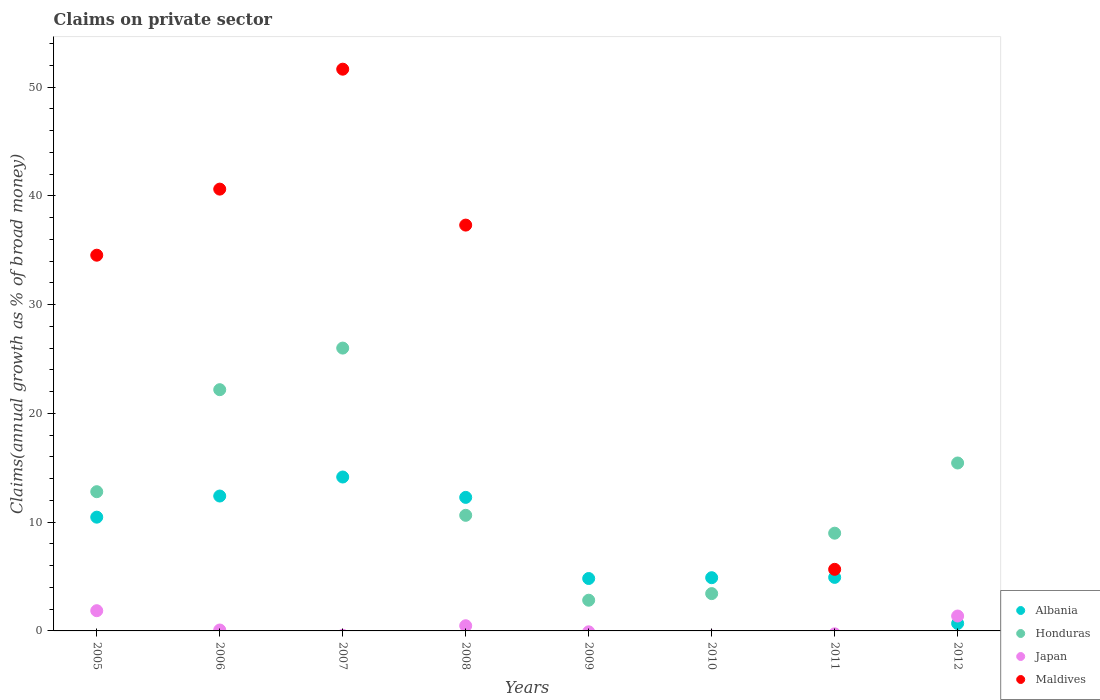How many different coloured dotlines are there?
Offer a terse response. 4. What is the percentage of broad money claimed on private sector in Albania in 2006?
Offer a terse response. 12.41. Across all years, what is the maximum percentage of broad money claimed on private sector in Maldives?
Your response must be concise. 51.66. What is the total percentage of broad money claimed on private sector in Honduras in the graph?
Offer a very short reply. 102.32. What is the difference between the percentage of broad money claimed on private sector in Honduras in 2006 and that in 2008?
Offer a terse response. 11.55. What is the difference between the percentage of broad money claimed on private sector in Honduras in 2011 and the percentage of broad money claimed on private sector in Japan in 2005?
Offer a terse response. 7.13. What is the average percentage of broad money claimed on private sector in Japan per year?
Your answer should be compact. 0.47. In the year 2009, what is the difference between the percentage of broad money claimed on private sector in Albania and percentage of broad money claimed on private sector in Honduras?
Your answer should be compact. 2. In how many years, is the percentage of broad money claimed on private sector in Albania greater than 50 %?
Offer a terse response. 0. What is the ratio of the percentage of broad money claimed on private sector in Japan in 2006 to that in 2012?
Provide a short and direct response. 0.06. Is the difference between the percentage of broad money claimed on private sector in Albania in 2005 and 2011 greater than the difference between the percentage of broad money claimed on private sector in Honduras in 2005 and 2011?
Offer a terse response. Yes. What is the difference between the highest and the second highest percentage of broad money claimed on private sector in Japan?
Provide a short and direct response. 0.49. What is the difference between the highest and the lowest percentage of broad money claimed on private sector in Japan?
Your answer should be very brief. 1.86. Is the sum of the percentage of broad money claimed on private sector in Honduras in 2006 and 2011 greater than the maximum percentage of broad money claimed on private sector in Maldives across all years?
Make the answer very short. No. Does the percentage of broad money claimed on private sector in Japan monotonically increase over the years?
Keep it short and to the point. No. Is the percentage of broad money claimed on private sector in Japan strictly greater than the percentage of broad money claimed on private sector in Albania over the years?
Give a very brief answer. No. Is the percentage of broad money claimed on private sector in Maldives strictly less than the percentage of broad money claimed on private sector in Japan over the years?
Your answer should be compact. No. How many dotlines are there?
Make the answer very short. 4. How many years are there in the graph?
Your response must be concise. 8. What is the difference between two consecutive major ticks on the Y-axis?
Ensure brevity in your answer.  10. Are the values on the major ticks of Y-axis written in scientific E-notation?
Give a very brief answer. No. Does the graph contain grids?
Your answer should be compact. No. How many legend labels are there?
Your answer should be compact. 4. How are the legend labels stacked?
Provide a succinct answer. Vertical. What is the title of the graph?
Provide a succinct answer. Claims on private sector. Does "Latin America(all income levels)" appear as one of the legend labels in the graph?
Your answer should be compact. No. What is the label or title of the X-axis?
Give a very brief answer. Years. What is the label or title of the Y-axis?
Make the answer very short. Claims(annual growth as % of broad money). What is the Claims(annual growth as % of broad money) of Albania in 2005?
Give a very brief answer. 10.46. What is the Claims(annual growth as % of broad money) in Honduras in 2005?
Provide a short and direct response. 12.8. What is the Claims(annual growth as % of broad money) of Japan in 2005?
Make the answer very short. 1.86. What is the Claims(annual growth as % of broad money) of Maldives in 2005?
Make the answer very short. 34.55. What is the Claims(annual growth as % of broad money) of Albania in 2006?
Provide a short and direct response. 12.41. What is the Claims(annual growth as % of broad money) in Honduras in 2006?
Provide a succinct answer. 22.19. What is the Claims(annual growth as % of broad money) of Japan in 2006?
Provide a short and direct response. 0.08. What is the Claims(annual growth as % of broad money) in Maldives in 2006?
Make the answer very short. 40.63. What is the Claims(annual growth as % of broad money) in Albania in 2007?
Your answer should be very brief. 14.15. What is the Claims(annual growth as % of broad money) of Honduras in 2007?
Make the answer very short. 26.01. What is the Claims(annual growth as % of broad money) in Japan in 2007?
Your answer should be compact. 0. What is the Claims(annual growth as % of broad money) in Maldives in 2007?
Keep it short and to the point. 51.66. What is the Claims(annual growth as % of broad money) in Albania in 2008?
Your answer should be compact. 12.28. What is the Claims(annual growth as % of broad money) of Honduras in 2008?
Make the answer very short. 10.63. What is the Claims(annual growth as % of broad money) of Japan in 2008?
Give a very brief answer. 0.48. What is the Claims(annual growth as % of broad money) of Maldives in 2008?
Give a very brief answer. 37.32. What is the Claims(annual growth as % of broad money) of Albania in 2009?
Ensure brevity in your answer.  4.82. What is the Claims(annual growth as % of broad money) in Honduras in 2009?
Make the answer very short. 2.82. What is the Claims(annual growth as % of broad money) in Maldives in 2009?
Ensure brevity in your answer.  0. What is the Claims(annual growth as % of broad money) of Albania in 2010?
Your answer should be compact. 4.89. What is the Claims(annual growth as % of broad money) in Honduras in 2010?
Your answer should be very brief. 3.43. What is the Claims(annual growth as % of broad money) in Albania in 2011?
Your response must be concise. 4.92. What is the Claims(annual growth as % of broad money) of Honduras in 2011?
Ensure brevity in your answer.  8.99. What is the Claims(annual growth as % of broad money) of Maldives in 2011?
Offer a very short reply. 5.66. What is the Claims(annual growth as % of broad money) of Albania in 2012?
Make the answer very short. 0.69. What is the Claims(annual growth as % of broad money) in Honduras in 2012?
Keep it short and to the point. 15.44. What is the Claims(annual growth as % of broad money) in Japan in 2012?
Make the answer very short. 1.37. What is the Claims(annual growth as % of broad money) of Maldives in 2012?
Make the answer very short. 0. Across all years, what is the maximum Claims(annual growth as % of broad money) in Albania?
Your answer should be compact. 14.15. Across all years, what is the maximum Claims(annual growth as % of broad money) in Honduras?
Keep it short and to the point. 26.01. Across all years, what is the maximum Claims(annual growth as % of broad money) in Japan?
Offer a terse response. 1.86. Across all years, what is the maximum Claims(annual growth as % of broad money) of Maldives?
Provide a succinct answer. 51.66. Across all years, what is the minimum Claims(annual growth as % of broad money) in Albania?
Provide a short and direct response. 0.69. Across all years, what is the minimum Claims(annual growth as % of broad money) of Honduras?
Your answer should be very brief. 2.82. Across all years, what is the minimum Claims(annual growth as % of broad money) of Japan?
Your answer should be very brief. 0. Across all years, what is the minimum Claims(annual growth as % of broad money) in Maldives?
Provide a succinct answer. 0. What is the total Claims(annual growth as % of broad money) of Albania in the graph?
Ensure brevity in your answer.  64.63. What is the total Claims(annual growth as % of broad money) of Honduras in the graph?
Your answer should be very brief. 102.32. What is the total Claims(annual growth as % of broad money) in Japan in the graph?
Ensure brevity in your answer.  3.79. What is the total Claims(annual growth as % of broad money) of Maldives in the graph?
Keep it short and to the point. 169.83. What is the difference between the Claims(annual growth as % of broad money) of Albania in 2005 and that in 2006?
Give a very brief answer. -1.94. What is the difference between the Claims(annual growth as % of broad money) in Honduras in 2005 and that in 2006?
Provide a succinct answer. -9.38. What is the difference between the Claims(annual growth as % of broad money) in Japan in 2005 and that in 2006?
Your answer should be very brief. 1.78. What is the difference between the Claims(annual growth as % of broad money) of Maldives in 2005 and that in 2006?
Provide a short and direct response. -6.08. What is the difference between the Claims(annual growth as % of broad money) of Albania in 2005 and that in 2007?
Provide a short and direct response. -3.69. What is the difference between the Claims(annual growth as % of broad money) of Honduras in 2005 and that in 2007?
Keep it short and to the point. -13.21. What is the difference between the Claims(annual growth as % of broad money) of Maldives in 2005 and that in 2007?
Provide a short and direct response. -17.11. What is the difference between the Claims(annual growth as % of broad money) in Albania in 2005 and that in 2008?
Provide a succinct answer. -1.82. What is the difference between the Claims(annual growth as % of broad money) of Honduras in 2005 and that in 2008?
Your answer should be very brief. 2.17. What is the difference between the Claims(annual growth as % of broad money) of Japan in 2005 and that in 2008?
Keep it short and to the point. 1.38. What is the difference between the Claims(annual growth as % of broad money) of Maldives in 2005 and that in 2008?
Make the answer very short. -2.77. What is the difference between the Claims(annual growth as % of broad money) of Albania in 2005 and that in 2009?
Offer a terse response. 5.64. What is the difference between the Claims(annual growth as % of broad money) in Honduras in 2005 and that in 2009?
Provide a short and direct response. 9.98. What is the difference between the Claims(annual growth as % of broad money) in Albania in 2005 and that in 2010?
Your response must be concise. 5.57. What is the difference between the Claims(annual growth as % of broad money) in Honduras in 2005 and that in 2010?
Provide a succinct answer. 9.37. What is the difference between the Claims(annual growth as % of broad money) in Albania in 2005 and that in 2011?
Provide a succinct answer. 5.54. What is the difference between the Claims(annual growth as % of broad money) of Honduras in 2005 and that in 2011?
Your answer should be very brief. 3.82. What is the difference between the Claims(annual growth as % of broad money) of Maldives in 2005 and that in 2011?
Your answer should be very brief. 28.89. What is the difference between the Claims(annual growth as % of broad money) of Albania in 2005 and that in 2012?
Your response must be concise. 9.77. What is the difference between the Claims(annual growth as % of broad money) of Honduras in 2005 and that in 2012?
Your answer should be very brief. -2.64. What is the difference between the Claims(annual growth as % of broad money) in Japan in 2005 and that in 2012?
Ensure brevity in your answer.  0.49. What is the difference between the Claims(annual growth as % of broad money) in Albania in 2006 and that in 2007?
Give a very brief answer. -1.75. What is the difference between the Claims(annual growth as % of broad money) of Honduras in 2006 and that in 2007?
Give a very brief answer. -3.83. What is the difference between the Claims(annual growth as % of broad money) in Maldives in 2006 and that in 2007?
Provide a succinct answer. -11.03. What is the difference between the Claims(annual growth as % of broad money) of Albania in 2006 and that in 2008?
Keep it short and to the point. 0.12. What is the difference between the Claims(annual growth as % of broad money) in Honduras in 2006 and that in 2008?
Ensure brevity in your answer.  11.55. What is the difference between the Claims(annual growth as % of broad money) of Japan in 2006 and that in 2008?
Your answer should be very brief. -0.39. What is the difference between the Claims(annual growth as % of broad money) in Maldives in 2006 and that in 2008?
Your answer should be very brief. 3.31. What is the difference between the Claims(annual growth as % of broad money) of Albania in 2006 and that in 2009?
Offer a very short reply. 7.58. What is the difference between the Claims(annual growth as % of broad money) of Honduras in 2006 and that in 2009?
Offer a terse response. 19.36. What is the difference between the Claims(annual growth as % of broad money) of Albania in 2006 and that in 2010?
Your answer should be very brief. 7.51. What is the difference between the Claims(annual growth as % of broad money) in Honduras in 2006 and that in 2010?
Your response must be concise. 18.75. What is the difference between the Claims(annual growth as % of broad money) of Albania in 2006 and that in 2011?
Offer a very short reply. 7.48. What is the difference between the Claims(annual growth as % of broad money) of Honduras in 2006 and that in 2011?
Provide a succinct answer. 13.2. What is the difference between the Claims(annual growth as % of broad money) in Maldives in 2006 and that in 2011?
Give a very brief answer. 34.97. What is the difference between the Claims(annual growth as % of broad money) in Albania in 2006 and that in 2012?
Offer a terse response. 11.72. What is the difference between the Claims(annual growth as % of broad money) in Honduras in 2006 and that in 2012?
Offer a very short reply. 6.74. What is the difference between the Claims(annual growth as % of broad money) of Japan in 2006 and that in 2012?
Ensure brevity in your answer.  -1.29. What is the difference between the Claims(annual growth as % of broad money) in Albania in 2007 and that in 2008?
Offer a very short reply. 1.87. What is the difference between the Claims(annual growth as % of broad money) in Honduras in 2007 and that in 2008?
Your response must be concise. 15.38. What is the difference between the Claims(annual growth as % of broad money) of Maldives in 2007 and that in 2008?
Ensure brevity in your answer.  14.34. What is the difference between the Claims(annual growth as % of broad money) of Albania in 2007 and that in 2009?
Provide a succinct answer. 9.33. What is the difference between the Claims(annual growth as % of broad money) of Honduras in 2007 and that in 2009?
Ensure brevity in your answer.  23.19. What is the difference between the Claims(annual growth as % of broad money) in Albania in 2007 and that in 2010?
Your response must be concise. 9.26. What is the difference between the Claims(annual growth as % of broad money) of Honduras in 2007 and that in 2010?
Your answer should be very brief. 22.58. What is the difference between the Claims(annual growth as % of broad money) in Albania in 2007 and that in 2011?
Make the answer very short. 9.23. What is the difference between the Claims(annual growth as % of broad money) of Honduras in 2007 and that in 2011?
Your response must be concise. 17.02. What is the difference between the Claims(annual growth as % of broad money) of Maldives in 2007 and that in 2011?
Make the answer very short. 46. What is the difference between the Claims(annual growth as % of broad money) in Albania in 2007 and that in 2012?
Provide a short and direct response. 13.47. What is the difference between the Claims(annual growth as % of broad money) of Honduras in 2007 and that in 2012?
Your response must be concise. 10.57. What is the difference between the Claims(annual growth as % of broad money) in Albania in 2008 and that in 2009?
Keep it short and to the point. 7.46. What is the difference between the Claims(annual growth as % of broad money) in Honduras in 2008 and that in 2009?
Your answer should be very brief. 7.81. What is the difference between the Claims(annual growth as % of broad money) in Albania in 2008 and that in 2010?
Offer a very short reply. 7.39. What is the difference between the Claims(annual growth as % of broad money) in Honduras in 2008 and that in 2010?
Keep it short and to the point. 7.2. What is the difference between the Claims(annual growth as % of broad money) of Albania in 2008 and that in 2011?
Offer a very short reply. 7.36. What is the difference between the Claims(annual growth as % of broad money) of Honduras in 2008 and that in 2011?
Make the answer very short. 1.64. What is the difference between the Claims(annual growth as % of broad money) in Maldives in 2008 and that in 2011?
Your answer should be very brief. 31.66. What is the difference between the Claims(annual growth as % of broad money) in Albania in 2008 and that in 2012?
Keep it short and to the point. 11.59. What is the difference between the Claims(annual growth as % of broad money) in Honduras in 2008 and that in 2012?
Offer a very short reply. -4.81. What is the difference between the Claims(annual growth as % of broad money) in Japan in 2008 and that in 2012?
Give a very brief answer. -0.89. What is the difference between the Claims(annual growth as % of broad money) in Albania in 2009 and that in 2010?
Provide a short and direct response. -0.07. What is the difference between the Claims(annual growth as % of broad money) of Honduras in 2009 and that in 2010?
Ensure brevity in your answer.  -0.61. What is the difference between the Claims(annual growth as % of broad money) in Albania in 2009 and that in 2011?
Your answer should be compact. -0.1. What is the difference between the Claims(annual growth as % of broad money) in Honduras in 2009 and that in 2011?
Your answer should be very brief. -6.16. What is the difference between the Claims(annual growth as % of broad money) in Albania in 2009 and that in 2012?
Provide a short and direct response. 4.13. What is the difference between the Claims(annual growth as % of broad money) in Honduras in 2009 and that in 2012?
Offer a terse response. -12.62. What is the difference between the Claims(annual growth as % of broad money) of Albania in 2010 and that in 2011?
Keep it short and to the point. -0.03. What is the difference between the Claims(annual growth as % of broad money) of Honduras in 2010 and that in 2011?
Provide a short and direct response. -5.56. What is the difference between the Claims(annual growth as % of broad money) of Albania in 2010 and that in 2012?
Ensure brevity in your answer.  4.21. What is the difference between the Claims(annual growth as % of broad money) of Honduras in 2010 and that in 2012?
Offer a terse response. -12.01. What is the difference between the Claims(annual growth as % of broad money) of Albania in 2011 and that in 2012?
Keep it short and to the point. 4.24. What is the difference between the Claims(annual growth as % of broad money) of Honduras in 2011 and that in 2012?
Keep it short and to the point. -6.46. What is the difference between the Claims(annual growth as % of broad money) of Albania in 2005 and the Claims(annual growth as % of broad money) of Honduras in 2006?
Your answer should be very brief. -11.72. What is the difference between the Claims(annual growth as % of broad money) in Albania in 2005 and the Claims(annual growth as % of broad money) in Japan in 2006?
Ensure brevity in your answer.  10.38. What is the difference between the Claims(annual growth as % of broad money) in Albania in 2005 and the Claims(annual growth as % of broad money) in Maldives in 2006?
Provide a short and direct response. -30.17. What is the difference between the Claims(annual growth as % of broad money) of Honduras in 2005 and the Claims(annual growth as % of broad money) of Japan in 2006?
Offer a terse response. 12.72. What is the difference between the Claims(annual growth as % of broad money) in Honduras in 2005 and the Claims(annual growth as % of broad money) in Maldives in 2006?
Provide a succinct answer. -27.83. What is the difference between the Claims(annual growth as % of broad money) in Japan in 2005 and the Claims(annual growth as % of broad money) in Maldives in 2006?
Your answer should be compact. -38.77. What is the difference between the Claims(annual growth as % of broad money) of Albania in 2005 and the Claims(annual growth as % of broad money) of Honduras in 2007?
Ensure brevity in your answer.  -15.55. What is the difference between the Claims(annual growth as % of broad money) in Albania in 2005 and the Claims(annual growth as % of broad money) in Maldives in 2007?
Give a very brief answer. -41.2. What is the difference between the Claims(annual growth as % of broad money) of Honduras in 2005 and the Claims(annual growth as % of broad money) of Maldives in 2007?
Offer a terse response. -38.86. What is the difference between the Claims(annual growth as % of broad money) in Japan in 2005 and the Claims(annual growth as % of broad money) in Maldives in 2007?
Provide a succinct answer. -49.8. What is the difference between the Claims(annual growth as % of broad money) in Albania in 2005 and the Claims(annual growth as % of broad money) in Honduras in 2008?
Offer a very short reply. -0.17. What is the difference between the Claims(annual growth as % of broad money) in Albania in 2005 and the Claims(annual growth as % of broad money) in Japan in 2008?
Provide a short and direct response. 9.99. What is the difference between the Claims(annual growth as % of broad money) of Albania in 2005 and the Claims(annual growth as % of broad money) of Maldives in 2008?
Offer a terse response. -26.86. What is the difference between the Claims(annual growth as % of broad money) of Honduras in 2005 and the Claims(annual growth as % of broad money) of Japan in 2008?
Provide a succinct answer. 12.33. What is the difference between the Claims(annual growth as % of broad money) of Honduras in 2005 and the Claims(annual growth as % of broad money) of Maldives in 2008?
Your answer should be very brief. -24.52. What is the difference between the Claims(annual growth as % of broad money) of Japan in 2005 and the Claims(annual growth as % of broad money) of Maldives in 2008?
Offer a terse response. -35.46. What is the difference between the Claims(annual growth as % of broad money) of Albania in 2005 and the Claims(annual growth as % of broad money) of Honduras in 2009?
Make the answer very short. 7.64. What is the difference between the Claims(annual growth as % of broad money) in Albania in 2005 and the Claims(annual growth as % of broad money) in Honduras in 2010?
Make the answer very short. 7.03. What is the difference between the Claims(annual growth as % of broad money) in Albania in 2005 and the Claims(annual growth as % of broad money) in Honduras in 2011?
Provide a short and direct response. 1.47. What is the difference between the Claims(annual growth as % of broad money) in Albania in 2005 and the Claims(annual growth as % of broad money) in Maldives in 2011?
Your answer should be very brief. 4.8. What is the difference between the Claims(annual growth as % of broad money) in Honduras in 2005 and the Claims(annual growth as % of broad money) in Maldives in 2011?
Ensure brevity in your answer.  7.14. What is the difference between the Claims(annual growth as % of broad money) of Japan in 2005 and the Claims(annual growth as % of broad money) of Maldives in 2011?
Ensure brevity in your answer.  -3.8. What is the difference between the Claims(annual growth as % of broad money) in Albania in 2005 and the Claims(annual growth as % of broad money) in Honduras in 2012?
Offer a very short reply. -4.98. What is the difference between the Claims(annual growth as % of broad money) in Albania in 2005 and the Claims(annual growth as % of broad money) in Japan in 2012?
Provide a succinct answer. 9.09. What is the difference between the Claims(annual growth as % of broad money) in Honduras in 2005 and the Claims(annual growth as % of broad money) in Japan in 2012?
Make the answer very short. 11.43. What is the difference between the Claims(annual growth as % of broad money) in Albania in 2006 and the Claims(annual growth as % of broad money) in Honduras in 2007?
Your answer should be very brief. -13.61. What is the difference between the Claims(annual growth as % of broad money) of Albania in 2006 and the Claims(annual growth as % of broad money) of Maldives in 2007?
Your answer should be very brief. -39.26. What is the difference between the Claims(annual growth as % of broad money) in Honduras in 2006 and the Claims(annual growth as % of broad money) in Maldives in 2007?
Give a very brief answer. -29.48. What is the difference between the Claims(annual growth as % of broad money) in Japan in 2006 and the Claims(annual growth as % of broad money) in Maldives in 2007?
Offer a very short reply. -51.58. What is the difference between the Claims(annual growth as % of broad money) of Albania in 2006 and the Claims(annual growth as % of broad money) of Honduras in 2008?
Your response must be concise. 1.77. What is the difference between the Claims(annual growth as % of broad money) of Albania in 2006 and the Claims(annual growth as % of broad money) of Japan in 2008?
Provide a succinct answer. 11.93. What is the difference between the Claims(annual growth as % of broad money) in Albania in 2006 and the Claims(annual growth as % of broad money) in Maldives in 2008?
Ensure brevity in your answer.  -24.92. What is the difference between the Claims(annual growth as % of broad money) in Honduras in 2006 and the Claims(annual growth as % of broad money) in Japan in 2008?
Your response must be concise. 21.71. What is the difference between the Claims(annual growth as % of broad money) of Honduras in 2006 and the Claims(annual growth as % of broad money) of Maldives in 2008?
Your answer should be very brief. -15.14. What is the difference between the Claims(annual growth as % of broad money) of Japan in 2006 and the Claims(annual growth as % of broad money) of Maldives in 2008?
Your response must be concise. -37.24. What is the difference between the Claims(annual growth as % of broad money) in Albania in 2006 and the Claims(annual growth as % of broad money) in Honduras in 2009?
Give a very brief answer. 9.58. What is the difference between the Claims(annual growth as % of broad money) in Albania in 2006 and the Claims(annual growth as % of broad money) in Honduras in 2010?
Provide a short and direct response. 8.97. What is the difference between the Claims(annual growth as % of broad money) of Albania in 2006 and the Claims(annual growth as % of broad money) of Honduras in 2011?
Your answer should be very brief. 3.42. What is the difference between the Claims(annual growth as % of broad money) of Albania in 2006 and the Claims(annual growth as % of broad money) of Maldives in 2011?
Keep it short and to the point. 6.74. What is the difference between the Claims(annual growth as % of broad money) in Honduras in 2006 and the Claims(annual growth as % of broad money) in Maldives in 2011?
Make the answer very short. 16.52. What is the difference between the Claims(annual growth as % of broad money) in Japan in 2006 and the Claims(annual growth as % of broad money) in Maldives in 2011?
Offer a terse response. -5.58. What is the difference between the Claims(annual growth as % of broad money) in Albania in 2006 and the Claims(annual growth as % of broad money) in Honduras in 2012?
Give a very brief answer. -3.04. What is the difference between the Claims(annual growth as % of broad money) in Albania in 2006 and the Claims(annual growth as % of broad money) in Japan in 2012?
Ensure brevity in your answer.  11.03. What is the difference between the Claims(annual growth as % of broad money) in Honduras in 2006 and the Claims(annual growth as % of broad money) in Japan in 2012?
Your answer should be very brief. 20.81. What is the difference between the Claims(annual growth as % of broad money) of Albania in 2007 and the Claims(annual growth as % of broad money) of Honduras in 2008?
Your answer should be very brief. 3.52. What is the difference between the Claims(annual growth as % of broad money) of Albania in 2007 and the Claims(annual growth as % of broad money) of Japan in 2008?
Keep it short and to the point. 13.68. What is the difference between the Claims(annual growth as % of broad money) in Albania in 2007 and the Claims(annual growth as % of broad money) in Maldives in 2008?
Make the answer very short. -23.17. What is the difference between the Claims(annual growth as % of broad money) of Honduras in 2007 and the Claims(annual growth as % of broad money) of Japan in 2008?
Offer a terse response. 25.53. What is the difference between the Claims(annual growth as % of broad money) of Honduras in 2007 and the Claims(annual growth as % of broad money) of Maldives in 2008?
Provide a succinct answer. -11.31. What is the difference between the Claims(annual growth as % of broad money) in Albania in 2007 and the Claims(annual growth as % of broad money) in Honduras in 2009?
Make the answer very short. 11.33. What is the difference between the Claims(annual growth as % of broad money) of Albania in 2007 and the Claims(annual growth as % of broad money) of Honduras in 2010?
Provide a short and direct response. 10.72. What is the difference between the Claims(annual growth as % of broad money) in Albania in 2007 and the Claims(annual growth as % of broad money) in Honduras in 2011?
Offer a terse response. 5.17. What is the difference between the Claims(annual growth as % of broad money) in Albania in 2007 and the Claims(annual growth as % of broad money) in Maldives in 2011?
Offer a terse response. 8.49. What is the difference between the Claims(annual growth as % of broad money) in Honduras in 2007 and the Claims(annual growth as % of broad money) in Maldives in 2011?
Your answer should be very brief. 20.35. What is the difference between the Claims(annual growth as % of broad money) in Albania in 2007 and the Claims(annual growth as % of broad money) in Honduras in 2012?
Your response must be concise. -1.29. What is the difference between the Claims(annual growth as % of broad money) of Albania in 2007 and the Claims(annual growth as % of broad money) of Japan in 2012?
Your answer should be compact. 12.78. What is the difference between the Claims(annual growth as % of broad money) in Honduras in 2007 and the Claims(annual growth as % of broad money) in Japan in 2012?
Provide a short and direct response. 24.64. What is the difference between the Claims(annual growth as % of broad money) in Albania in 2008 and the Claims(annual growth as % of broad money) in Honduras in 2009?
Provide a short and direct response. 9.46. What is the difference between the Claims(annual growth as % of broad money) of Albania in 2008 and the Claims(annual growth as % of broad money) of Honduras in 2010?
Offer a very short reply. 8.85. What is the difference between the Claims(annual growth as % of broad money) of Albania in 2008 and the Claims(annual growth as % of broad money) of Honduras in 2011?
Ensure brevity in your answer.  3.29. What is the difference between the Claims(annual growth as % of broad money) in Albania in 2008 and the Claims(annual growth as % of broad money) in Maldives in 2011?
Keep it short and to the point. 6.62. What is the difference between the Claims(annual growth as % of broad money) in Honduras in 2008 and the Claims(annual growth as % of broad money) in Maldives in 2011?
Provide a short and direct response. 4.97. What is the difference between the Claims(annual growth as % of broad money) in Japan in 2008 and the Claims(annual growth as % of broad money) in Maldives in 2011?
Offer a terse response. -5.19. What is the difference between the Claims(annual growth as % of broad money) in Albania in 2008 and the Claims(annual growth as % of broad money) in Honduras in 2012?
Your answer should be very brief. -3.16. What is the difference between the Claims(annual growth as % of broad money) of Albania in 2008 and the Claims(annual growth as % of broad money) of Japan in 2012?
Give a very brief answer. 10.91. What is the difference between the Claims(annual growth as % of broad money) in Honduras in 2008 and the Claims(annual growth as % of broad money) in Japan in 2012?
Provide a short and direct response. 9.26. What is the difference between the Claims(annual growth as % of broad money) in Albania in 2009 and the Claims(annual growth as % of broad money) in Honduras in 2010?
Provide a short and direct response. 1.39. What is the difference between the Claims(annual growth as % of broad money) in Albania in 2009 and the Claims(annual growth as % of broad money) in Honduras in 2011?
Your response must be concise. -4.17. What is the difference between the Claims(annual growth as % of broad money) of Albania in 2009 and the Claims(annual growth as % of broad money) of Maldives in 2011?
Your answer should be compact. -0.84. What is the difference between the Claims(annual growth as % of broad money) of Honduras in 2009 and the Claims(annual growth as % of broad money) of Maldives in 2011?
Keep it short and to the point. -2.84. What is the difference between the Claims(annual growth as % of broad money) of Albania in 2009 and the Claims(annual growth as % of broad money) of Honduras in 2012?
Provide a succinct answer. -10.62. What is the difference between the Claims(annual growth as % of broad money) in Albania in 2009 and the Claims(annual growth as % of broad money) in Japan in 2012?
Keep it short and to the point. 3.45. What is the difference between the Claims(annual growth as % of broad money) in Honduras in 2009 and the Claims(annual growth as % of broad money) in Japan in 2012?
Provide a short and direct response. 1.45. What is the difference between the Claims(annual growth as % of broad money) of Albania in 2010 and the Claims(annual growth as % of broad money) of Honduras in 2011?
Offer a very short reply. -4.09. What is the difference between the Claims(annual growth as % of broad money) in Albania in 2010 and the Claims(annual growth as % of broad money) in Maldives in 2011?
Your response must be concise. -0.77. What is the difference between the Claims(annual growth as % of broad money) in Honduras in 2010 and the Claims(annual growth as % of broad money) in Maldives in 2011?
Offer a terse response. -2.23. What is the difference between the Claims(annual growth as % of broad money) of Albania in 2010 and the Claims(annual growth as % of broad money) of Honduras in 2012?
Give a very brief answer. -10.55. What is the difference between the Claims(annual growth as % of broad money) in Albania in 2010 and the Claims(annual growth as % of broad money) in Japan in 2012?
Your answer should be very brief. 3.52. What is the difference between the Claims(annual growth as % of broad money) in Honduras in 2010 and the Claims(annual growth as % of broad money) in Japan in 2012?
Ensure brevity in your answer.  2.06. What is the difference between the Claims(annual growth as % of broad money) of Albania in 2011 and the Claims(annual growth as % of broad money) of Honduras in 2012?
Ensure brevity in your answer.  -10.52. What is the difference between the Claims(annual growth as % of broad money) in Albania in 2011 and the Claims(annual growth as % of broad money) in Japan in 2012?
Offer a very short reply. 3.55. What is the difference between the Claims(annual growth as % of broad money) in Honduras in 2011 and the Claims(annual growth as % of broad money) in Japan in 2012?
Make the answer very short. 7.62. What is the average Claims(annual growth as % of broad money) in Albania per year?
Make the answer very short. 8.08. What is the average Claims(annual growth as % of broad money) of Honduras per year?
Provide a succinct answer. 12.79. What is the average Claims(annual growth as % of broad money) in Japan per year?
Keep it short and to the point. 0.47. What is the average Claims(annual growth as % of broad money) in Maldives per year?
Provide a short and direct response. 21.23. In the year 2005, what is the difference between the Claims(annual growth as % of broad money) of Albania and Claims(annual growth as % of broad money) of Honduras?
Your answer should be very brief. -2.34. In the year 2005, what is the difference between the Claims(annual growth as % of broad money) of Albania and Claims(annual growth as % of broad money) of Japan?
Make the answer very short. 8.6. In the year 2005, what is the difference between the Claims(annual growth as % of broad money) in Albania and Claims(annual growth as % of broad money) in Maldives?
Your answer should be compact. -24.09. In the year 2005, what is the difference between the Claims(annual growth as % of broad money) of Honduras and Claims(annual growth as % of broad money) of Japan?
Provide a succinct answer. 10.94. In the year 2005, what is the difference between the Claims(annual growth as % of broad money) of Honduras and Claims(annual growth as % of broad money) of Maldives?
Provide a short and direct response. -21.75. In the year 2005, what is the difference between the Claims(annual growth as % of broad money) in Japan and Claims(annual growth as % of broad money) in Maldives?
Provide a succinct answer. -32.69. In the year 2006, what is the difference between the Claims(annual growth as % of broad money) in Albania and Claims(annual growth as % of broad money) in Honduras?
Keep it short and to the point. -9.78. In the year 2006, what is the difference between the Claims(annual growth as % of broad money) of Albania and Claims(annual growth as % of broad money) of Japan?
Provide a succinct answer. 12.32. In the year 2006, what is the difference between the Claims(annual growth as % of broad money) in Albania and Claims(annual growth as % of broad money) in Maldives?
Offer a very short reply. -28.23. In the year 2006, what is the difference between the Claims(annual growth as % of broad money) in Honduras and Claims(annual growth as % of broad money) in Japan?
Ensure brevity in your answer.  22.1. In the year 2006, what is the difference between the Claims(annual growth as % of broad money) in Honduras and Claims(annual growth as % of broad money) in Maldives?
Your answer should be compact. -18.45. In the year 2006, what is the difference between the Claims(annual growth as % of broad money) of Japan and Claims(annual growth as % of broad money) of Maldives?
Your response must be concise. -40.55. In the year 2007, what is the difference between the Claims(annual growth as % of broad money) in Albania and Claims(annual growth as % of broad money) in Honduras?
Your answer should be compact. -11.86. In the year 2007, what is the difference between the Claims(annual growth as % of broad money) of Albania and Claims(annual growth as % of broad money) of Maldives?
Offer a very short reply. -37.51. In the year 2007, what is the difference between the Claims(annual growth as % of broad money) in Honduras and Claims(annual growth as % of broad money) in Maldives?
Ensure brevity in your answer.  -25.65. In the year 2008, what is the difference between the Claims(annual growth as % of broad money) of Albania and Claims(annual growth as % of broad money) of Honduras?
Your answer should be compact. 1.65. In the year 2008, what is the difference between the Claims(annual growth as % of broad money) in Albania and Claims(annual growth as % of broad money) in Japan?
Give a very brief answer. 11.8. In the year 2008, what is the difference between the Claims(annual growth as % of broad money) in Albania and Claims(annual growth as % of broad money) in Maldives?
Keep it short and to the point. -25.04. In the year 2008, what is the difference between the Claims(annual growth as % of broad money) of Honduras and Claims(annual growth as % of broad money) of Japan?
Ensure brevity in your answer.  10.15. In the year 2008, what is the difference between the Claims(annual growth as % of broad money) in Honduras and Claims(annual growth as % of broad money) in Maldives?
Provide a succinct answer. -26.69. In the year 2008, what is the difference between the Claims(annual growth as % of broad money) in Japan and Claims(annual growth as % of broad money) in Maldives?
Your answer should be very brief. -36.85. In the year 2009, what is the difference between the Claims(annual growth as % of broad money) of Albania and Claims(annual growth as % of broad money) of Honduras?
Give a very brief answer. 2. In the year 2010, what is the difference between the Claims(annual growth as % of broad money) in Albania and Claims(annual growth as % of broad money) in Honduras?
Your answer should be very brief. 1.46. In the year 2011, what is the difference between the Claims(annual growth as % of broad money) of Albania and Claims(annual growth as % of broad money) of Honduras?
Keep it short and to the point. -4.06. In the year 2011, what is the difference between the Claims(annual growth as % of broad money) of Albania and Claims(annual growth as % of broad money) of Maldives?
Offer a terse response. -0.74. In the year 2011, what is the difference between the Claims(annual growth as % of broad money) in Honduras and Claims(annual growth as % of broad money) in Maldives?
Keep it short and to the point. 3.33. In the year 2012, what is the difference between the Claims(annual growth as % of broad money) of Albania and Claims(annual growth as % of broad money) of Honduras?
Give a very brief answer. -14.76. In the year 2012, what is the difference between the Claims(annual growth as % of broad money) of Albania and Claims(annual growth as % of broad money) of Japan?
Keep it short and to the point. -0.68. In the year 2012, what is the difference between the Claims(annual growth as % of broad money) of Honduras and Claims(annual growth as % of broad money) of Japan?
Your answer should be very brief. 14.07. What is the ratio of the Claims(annual growth as % of broad money) in Albania in 2005 to that in 2006?
Your answer should be compact. 0.84. What is the ratio of the Claims(annual growth as % of broad money) of Honduras in 2005 to that in 2006?
Provide a succinct answer. 0.58. What is the ratio of the Claims(annual growth as % of broad money) in Japan in 2005 to that in 2006?
Your answer should be very brief. 22.02. What is the ratio of the Claims(annual growth as % of broad money) of Maldives in 2005 to that in 2006?
Provide a succinct answer. 0.85. What is the ratio of the Claims(annual growth as % of broad money) of Albania in 2005 to that in 2007?
Your answer should be compact. 0.74. What is the ratio of the Claims(annual growth as % of broad money) of Honduras in 2005 to that in 2007?
Provide a short and direct response. 0.49. What is the ratio of the Claims(annual growth as % of broad money) in Maldives in 2005 to that in 2007?
Ensure brevity in your answer.  0.67. What is the ratio of the Claims(annual growth as % of broad money) in Albania in 2005 to that in 2008?
Your response must be concise. 0.85. What is the ratio of the Claims(annual growth as % of broad money) in Honduras in 2005 to that in 2008?
Your answer should be very brief. 1.2. What is the ratio of the Claims(annual growth as % of broad money) in Japan in 2005 to that in 2008?
Ensure brevity in your answer.  3.9. What is the ratio of the Claims(annual growth as % of broad money) of Maldives in 2005 to that in 2008?
Provide a short and direct response. 0.93. What is the ratio of the Claims(annual growth as % of broad money) of Albania in 2005 to that in 2009?
Your response must be concise. 2.17. What is the ratio of the Claims(annual growth as % of broad money) of Honduras in 2005 to that in 2009?
Provide a succinct answer. 4.53. What is the ratio of the Claims(annual growth as % of broad money) of Albania in 2005 to that in 2010?
Make the answer very short. 2.14. What is the ratio of the Claims(annual growth as % of broad money) in Honduras in 2005 to that in 2010?
Your answer should be very brief. 3.73. What is the ratio of the Claims(annual growth as % of broad money) in Albania in 2005 to that in 2011?
Keep it short and to the point. 2.12. What is the ratio of the Claims(annual growth as % of broad money) in Honduras in 2005 to that in 2011?
Offer a very short reply. 1.42. What is the ratio of the Claims(annual growth as % of broad money) in Maldives in 2005 to that in 2011?
Ensure brevity in your answer.  6.1. What is the ratio of the Claims(annual growth as % of broad money) of Albania in 2005 to that in 2012?
Make the answer very short. 15.21. What is the ratio of the Claims(annual growth as % of broad money) of Honduras in 2005 to that in 2012?
Your response must be concise. 0.83. What is the ratio of the Claims(annual growth as % of broad money) in Japan in 2005 to that in 2012?
Your answer should be very brief. 1.36. What is the ratio of the Claims(annual growth as % of broad money) of Albania in 2006 to that in 2007?
Give a very brief answer. 0.88. What is the ratio of the Claims(annual growth as % of broad money) of Honduras in 2006 to that in 2007?
Ensure brevity in your answer.  0.85. What is the ratio of the Claims(annual growth as % of broad money) in Maldives in 2006 to that in 2007?
Provide a succinct answer. 0.79. What is the ratio of the Claims(annual growth as % of broad money) in Honduras in 2006 to that in 2008?
Your answer should be very brief. 2.09. What is the ratio of the Claims(annual growth as % of broad money) of Japan in 2006 to that in 2008?
Your response must be concise. 0.18. What is the ratio of the Claims(annual growth as % of broad money) of Maldives in 2006 to that in 2008?
Your answer should be compact. 1.09. What is the ratio of the Claims(annual growth as % of broad money) of Albania in 2006 to that in 2009?
Give a very brief answer. 2.57. What is the ratio of the Claims(annual growth as % of broad money) in Honduras in 2006 to that in 2009?
Provide a succinct answer. 7.86. What is the ratio of the Claims(annual growth as % of broad money) in Albania in 2006 to that in 2010?
Your response must be concise. 2.53. What is the ratio of the Claims(annual growth as % of broad money) in Honduras in 2006 to that in 2010?
Give a very brief answer. 6.47. What is the ratio of the Claims(annual growth as % of broad money) of Albania in 2006 to that in 2011?
Offer a terse response. 2.52. What is the ratio of the Claims(annual growth as % of broad money) of Honduras in 2006 to that in 2011?
Offer a very short reply. 2.47. What is the ratio of the Claims(annual growth as % of broad money) in Maldives in 2006 to that in 2011?
Offer a terse response. 7.17. What is the ratio of the Claims(annual growth as % of broad money) in Albania in 2006 to that in 2012?
Keep it short and to the point. 18.03. What is the ratio of the Claims(annual growth as % of broad money) in Honduras in 2006 to that in 2012?
Offer a very short reply. 1.44. What is the ratio of the Claims(annual growth as % of broad money) in Japan in 2006 to that in 2012?
Keep it short and to the point. 0.06. What is the ratio of the Claims(annual growth as % of broad money) in Albania in 2007 to that in 2008?
Provide a short and direct response. 1.15. What is the ratio of the Claims(annual growth as % of broad money) of Honduras in 2007 to that in 2008?
Your answer should be compact. 2.45. What is the ratio of the Claims(annual growth as % of broad money) of Maldives in 2007 to that in 2008?
Provide a succinct answer. 1.38. What is the ratio of the Claims(annual growth as % of broad money) in Albania in 2007 to that in 2009?
Your answer should be compact. 2.94. What is the ratio of the Claims(annual growth as % of broad money) of Honduras in 2007 to that in 2009?
Ensure brevity in your answer.  9.21. What is the ratio of the Claims(annual growth as % of broad money) of Albania in 2007 to that in 2010?
Give a very brief answer. 2.89. What is the ratio of the Claims(annual growth as % of broad money) of Honduras in 2007 to that in 2010?
Offer a terse response. 7.58. What is the ratio of the Claims(annual growth as % of broad money) of Albania in 2007 to that in 2011?
Ensure brevity in your answer.  2.87. What is the ratio of the Claims(annual growth as % of broad money) in Honduras in 2007 to that in 2011?
Make the answer very short. 2.89. What is the ratio of the Claims(annual growth as % of broad money) of Maldives in 2007 to that in 2011?
Ensure brevity in your answer.  9.12. What is the ratio of the Claims(annual growth as % of broad money) in Albania in 2007 to that in 2012?
Your answer should be very brief. 20.58. What is the ratio of the Claims(annual growth as % of broad money) of Honduras in 2007 to that in 2012?
Offer a terse response. 1.68. What is the ratio of the Claims(annual growth as % of broad money) in Albania in 2008 to that in 2009?
Your answer should be compact. 2.55. What is the ratio of the Claims(annual growth as % of broad money) in Honduras in 2008 to that in 2009?
Your answer should be very brief. 3.76. What is the ratio of the Claims(annual growth as % of broad money) in Albania in 2008 to that in 2010?
Your answer should be compact. 2.51. What is the ratio of the Claims(annual growth as % of broad money) of Honduras in 2008 to that in 2010?
Provide a short and direct response. 3.1. What is the ratio of the Claims(annual growth as % of broad money) of Albania in 2008 to that in 2011?
Keep it short and to the point. 2.49. What is the ratio of the Claims(annual growth as % of broad money) of Honduras in 2008 to that in 2011?
Provide a short and direct response. 1.18. What is the ratio of the Claims(annual growth as % of broad money) in Maldives in 2008 to that in 2011?
Provide a succinct answer. 6.59. What is the ratio of the Claims(annual growth as % of broad money) of Albania in 2008 to that in 2012?
Offer a very short reply. 17.85. What is the ratio of the Claims(annual growth as % of broad money) of Honduras in 2008 to that in 2012?
Give a very brief answer. 0.69. What is the ratio of the Claims(annual growth as % of broad money) of Japan in 2008 to that in 2012?
Your answer should be very brief. 0.35. What is the ratio of the Claims(annual growth as % of broad money) in Albania in 2009 to that in 2010?
Provide a short and direct response. 0.98. What is the ratio of the Claims(annual growth as % of broad money) in Honduras in 2009 to that in 2010?
Give a very brief answer. 0.82. What is the ratio of the Claims(annual growth as % of broad money) of Albania in 2009 to that in 2011?
Your response must be concise. 0.98. What is the ratio of the Claims(annual growth as % of broad money) in Honduras in 2009 to that in 2011?
Keep it short and to the point. 0.31. What is the ratio of the Claims(annual growth as % of broad money) in Albania in 2009 to that in 2012?
Provide a succinct answer. 7.01. What is the ratio of the Claims(annual growth as % of broad money) in Honduras in 2009 to that in 2012?
Your answer should be compact. 0.18. What is the ratio of the Claims(annual growth as % of broad money) in Albania in 2010 to that in 2011?
Provide a short and direct response. 0.99. What is the ratio of the Claims(annual growth as % of broad money) in Honduras in 2010 to that in 2011?
Your answer should be very brief. 0.38. What is the ratio of the Claims(annual growth as % of broad money) of Albania in 2010 to that in 2012?
Your answer should be compact. 7.11. What is the ratio of the Claims(annual growth as % of broad money) of Honduras in 2010 to that in 2012?
Give a very brief answer. 0.22. What is the ratio of the Claims(annual growth as % of broad money) of Albania in 2011 to that in 2012?
Keep it short and to the point. 7.16. What is the ratio of the Claims(annual growth as % of broad money) of Honduras in 2011 to that in 2012?
Provide a short and direct response. 0.58. What is the difference between the highest and the second highest Claims(annual growth as % of broad money) in Albania?
Offer a terse response. 1.75. What is the difference between the highest and the second highest Claims(annual growth as % of broad money) in Honduras?
Your answer should be very brief. 3.83. What is the difference between the highest and the second highest Claims(annual growth as % of broad money) of Japan?
Make the answer very short. 0.49. What is the difference between the highest and the second highest Claims(annual growth as % of broad money) in Maldives?
Give a very brief answer. 11.03. What is the difference between the highest and the lowest Claims(annual growth as % of broad money) in Albania?
Make the answer very short. 13.47. What is the difference between the highest and the lowest Claims(annual growth as % of broad money) in Honduras?
Provide a succinct answer. 23.19. What is the difference between the highest and the lowest Claims(annual growth as % of broad money) of Japan?
Ensure brevity in your answer.  1.86. What is the difference between the highest and the lowest Claims(annual growth as % of broad money) in Maldives?
Provide a short and direct response. 51.66. 